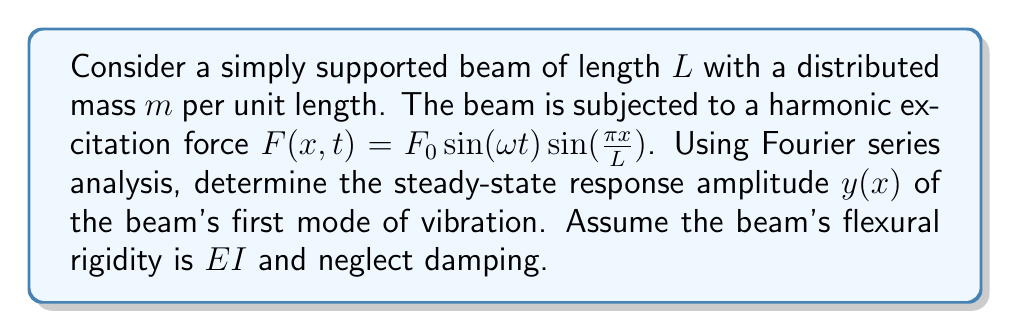Give your solution to this math problem. To solve this problem, we'll follow these steps:

1) First, recall that the equation of motion for a beam under forced vibration is:

   $$EI \frac{\partial^4 y}{\partial x^4} + m \frac{\partial^2 y}{\partial t^2} = F(x,t)$$

2) For the first mode of vibration, we can assume a solution of the form:

   $$y(x,t) = Y(x) \sin(\omega t)$$

3) Substituting this into the equation of motion:

   $$EI \frac{d^4 Y}{dx^4} - m\omega^2 Y = F_0 \sin(\frac{\pi x}{L})$$

4) The general solution for $Y(x)$ is:

   $$Y(x) = C_1 \sin(\frac{\pi x}{L}) + \frac{F_0 \sin(\frac{\pi x}{L})}{EI(\frac{\pi}{L})^4 - m\omega^2}$$

5) The first term represents the homogeneous solution, and the second term is the particular solution.

6) For a simply supported beam, the boundary conditions are $Y(0) = Y(L) = 0$, which are already satisfied by this solution.

7) The natural frequency of the first mode for a simply supported beam is:

   $$\omega_1 = \frac{\pi^2}{L^2}\sqrt{\frac{EI}{m}}$$

8) The steady-state response amplitude is given by the particular solution:

   $$Y(x) = \frac{F_0 \sin(\frac{\pi x}{L})}{EI(\frac{\pi}{L})^4 - m\omega^2}$$

9) This can be rewritten in terms of the natural frequency:

   $$Y(x) = \frac{F_0 L^4 \sin(\frac{\pi x}{L})}{EI\pi^4(1 - (\frac{\omega}{\omega_1})^2)}$$

This expression gives the amplitude of the steady-state response for the first mode of vibration as a function of position along the beam.
Answer: The steady-state response amplitude of the beam's first mode of vibration is:

$$Y(x) = \frac{F_0 L^4 \sin(\frac{\pi x}{L})}{EI\pi^4(1 - (\frac{\omega}{\omega_1})^2)}$$

where $\omega_1 = \frac{\pi^2}{L^2}\sqrt{\frac{EI}{m}}$ is the natural frequency of the first mode. 